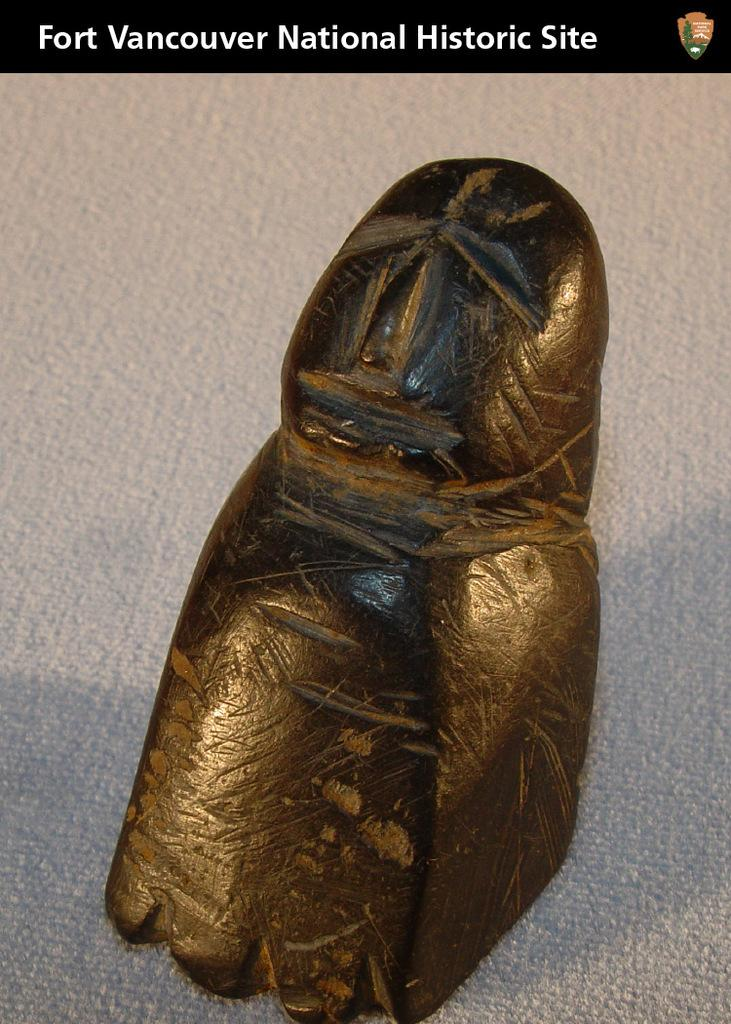What can be seen in the image? There is an object in the image. What is written or displayed at the top of the image? There is text at the top of the image. What type of thunder can be heard in the image? There is no thunder present in the image, as it is a visual medium and does not contain sound. 